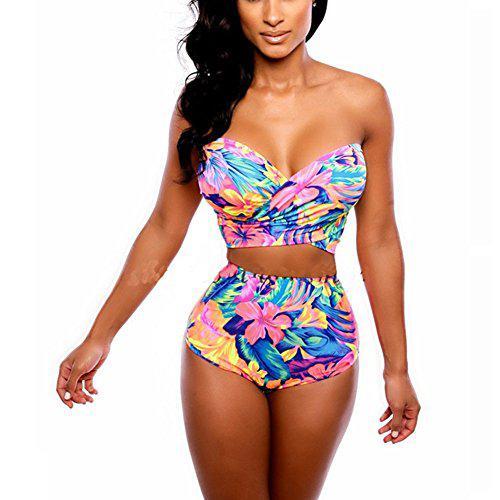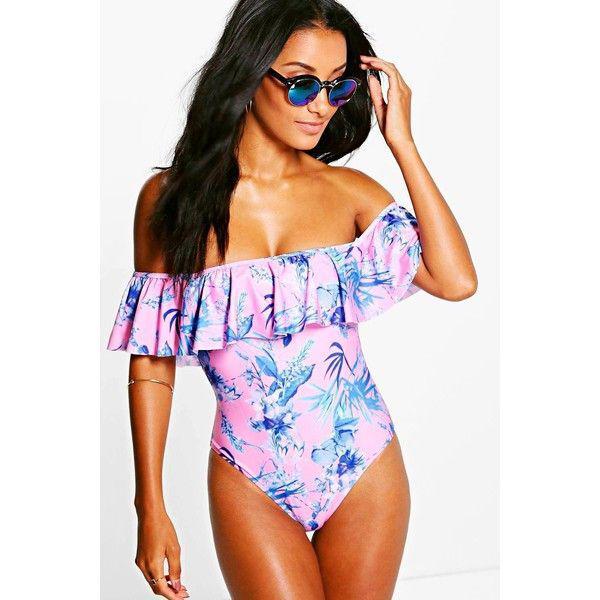The first image is the image on the left, the second image is the image on the right. Examine the images to the left and right. Is the description "One of the models is wearing sunglasses." accurate? Answer yes or no. Yes. 